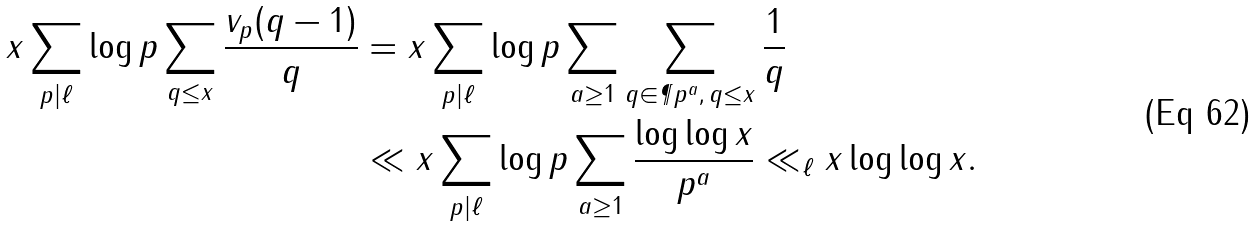Convert formula to latex. <formula><loc_0><loc_0><loc_500><loc_500>x \sum _ { p | \ell } \log p \sum _ { q \leq x } \frac { v _ { p } ( q - 1 ) } { q } & = x \sum _ { p | \ell } \log p \sum _ { a \geq 1 } \sum _ { q \in \P { p ^ { a } } , \, q \leq x } \frac { 1 } { q } \\ & \ll x \sum _ { p | \ell } \log p \sum _ { a \geq 1 } \frac { \log \log x } { p ^ { a } } \ll _ { \ell } x \log \log x .</formula> 